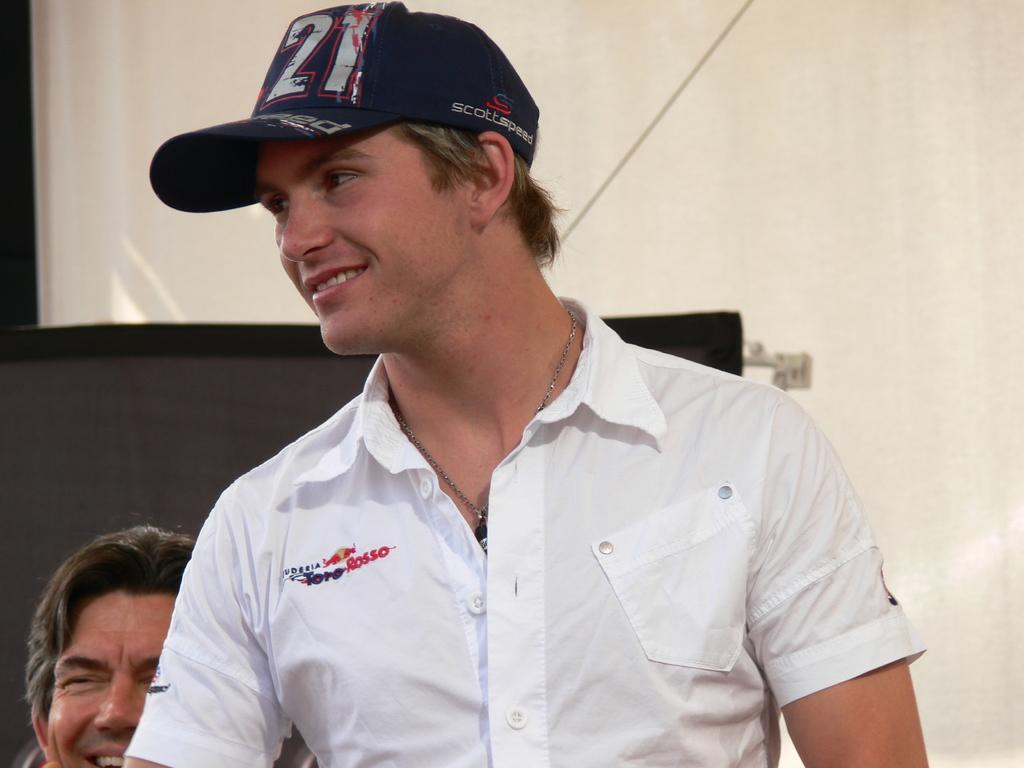What number is on his hat?
Make the answer very short. 21. 